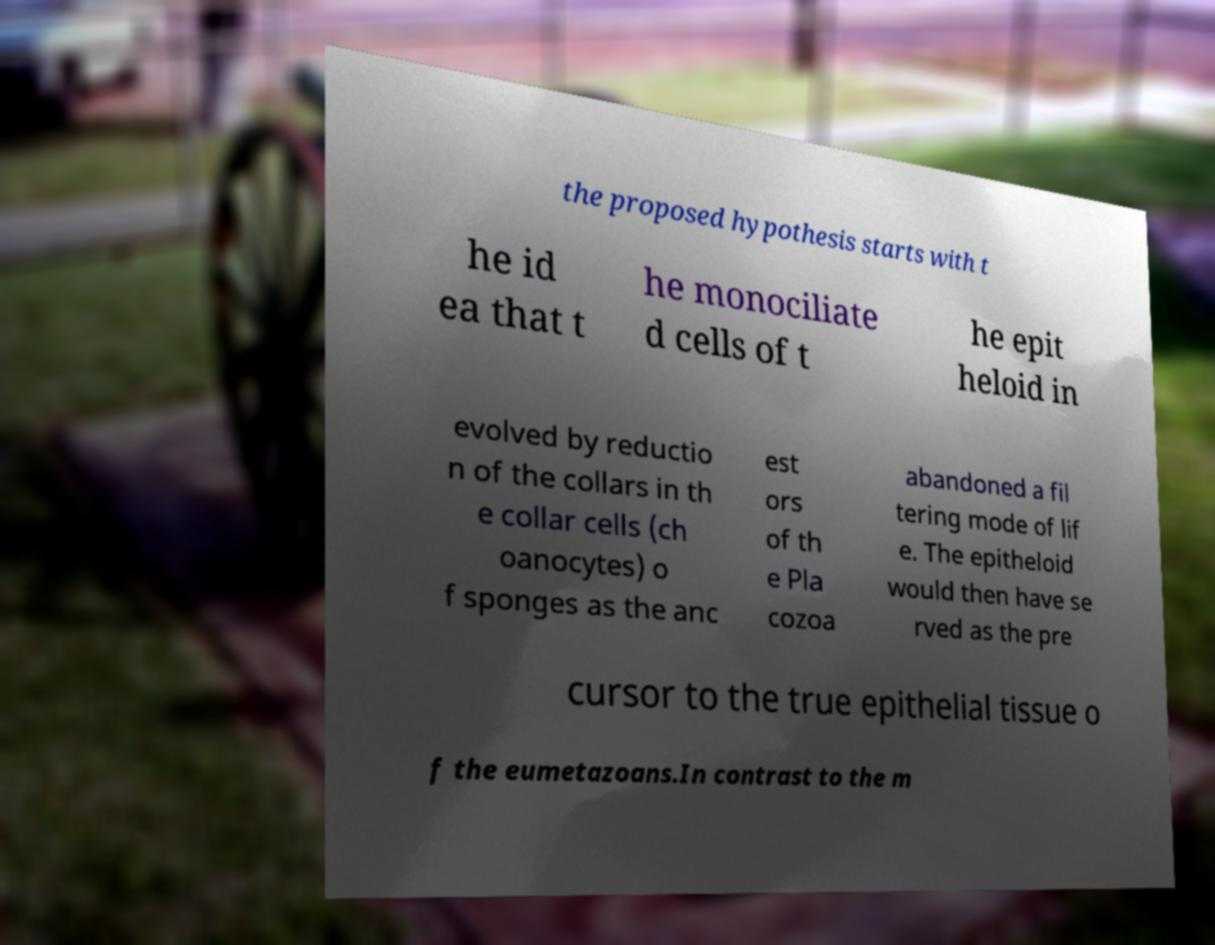I need the written content from this picture converted into text. Can you do that? the proposed hypothesis starts with t he id ea that t he monociliate d cells of t he epit heloid in evolved by reductio n of the collars in th e collar cells (ch oanocytes) o f sponges as the anc est ors of th e Pla cozoa abandoned a fil tering mode of lif e. The epitheloid would then have se rved as the pre cursor to the true epithelial tissue o f the eumetazoans.In contrast to the m 